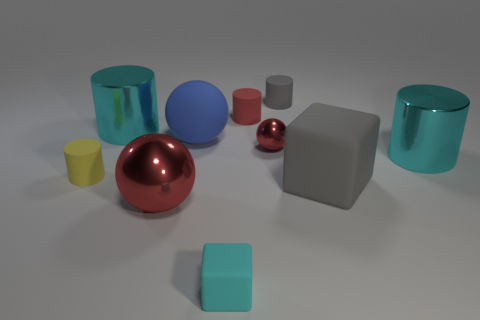Can you tell me about the variety of shapes present in this image? Certainly! In this image, there is a collection of geometric shapes. Specifically, there are spheres, cylinders, a cube, and what looks like a cuboid. Each shape contributes to a simple yet diverse composition, often used to study shading, lighting, and reflections in 3D modeling. 